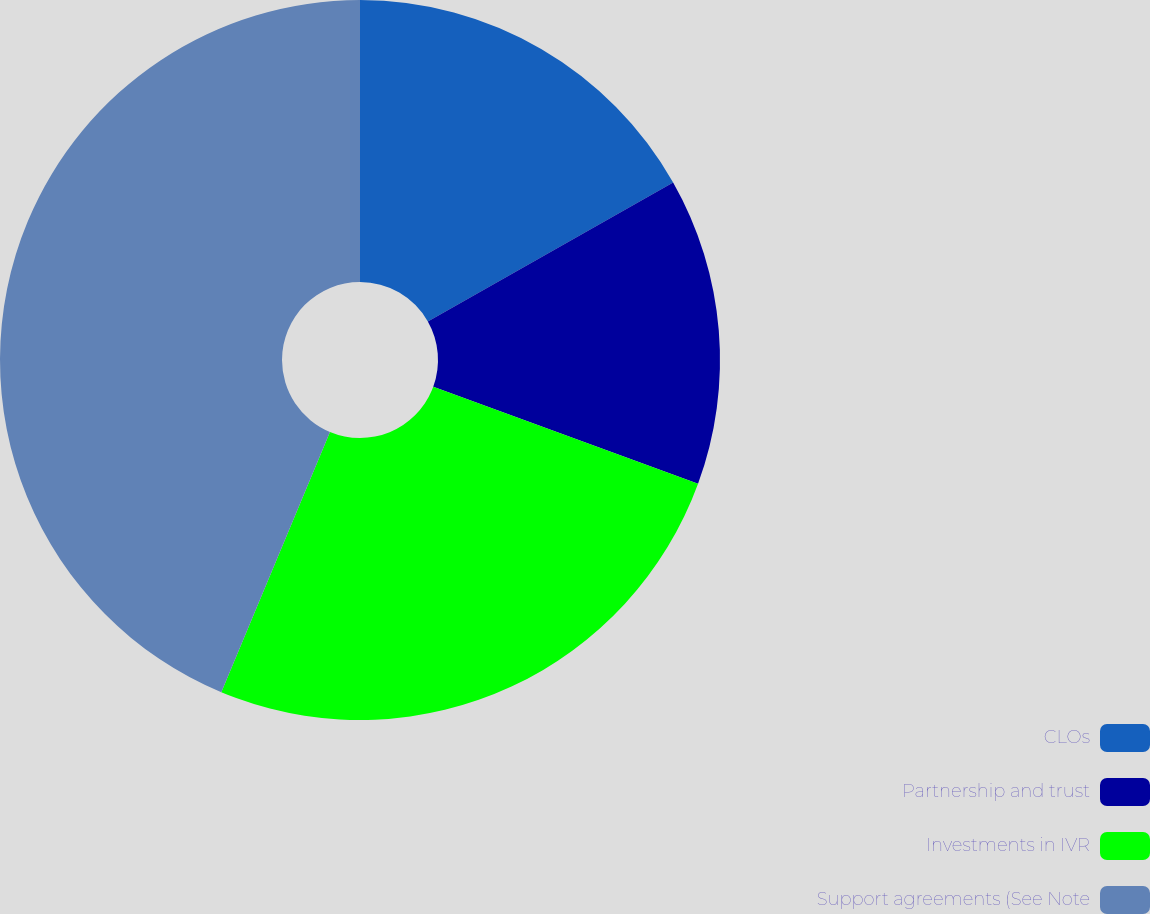Convert chart to OTSL. <chart><loc_0><loc_0><loc_500><loc_500><pie_chart><fcel>CLOs<fcel>Partnership and trust<fcel>Investments in IVR<fcel>Support agreements (See Note<nl><fcel>16.79%<fcel>13.8%<fcel>25.71%<fcel>43.71%<nl></chart> 